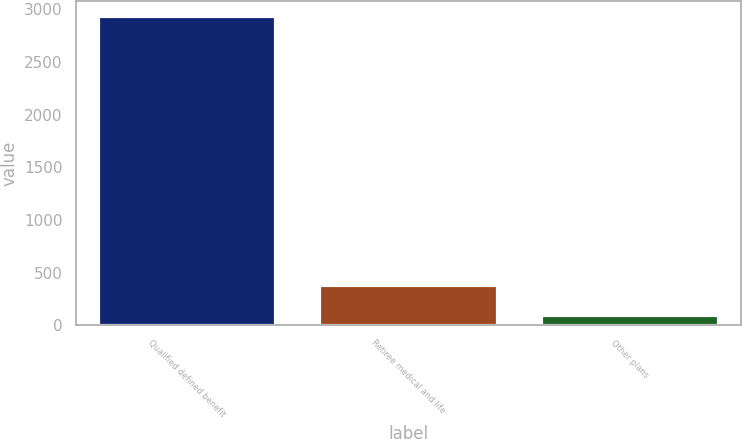Convert chart. <chart><loc_0><loc_0><loc_500><loc_500><bar_chart><fcel>Qualified defined benefit<fcel>Retiree medical and life<fcel>Other plans<nl><fcel>2933<fcel>381.5<fcel>98<nl></chart> 